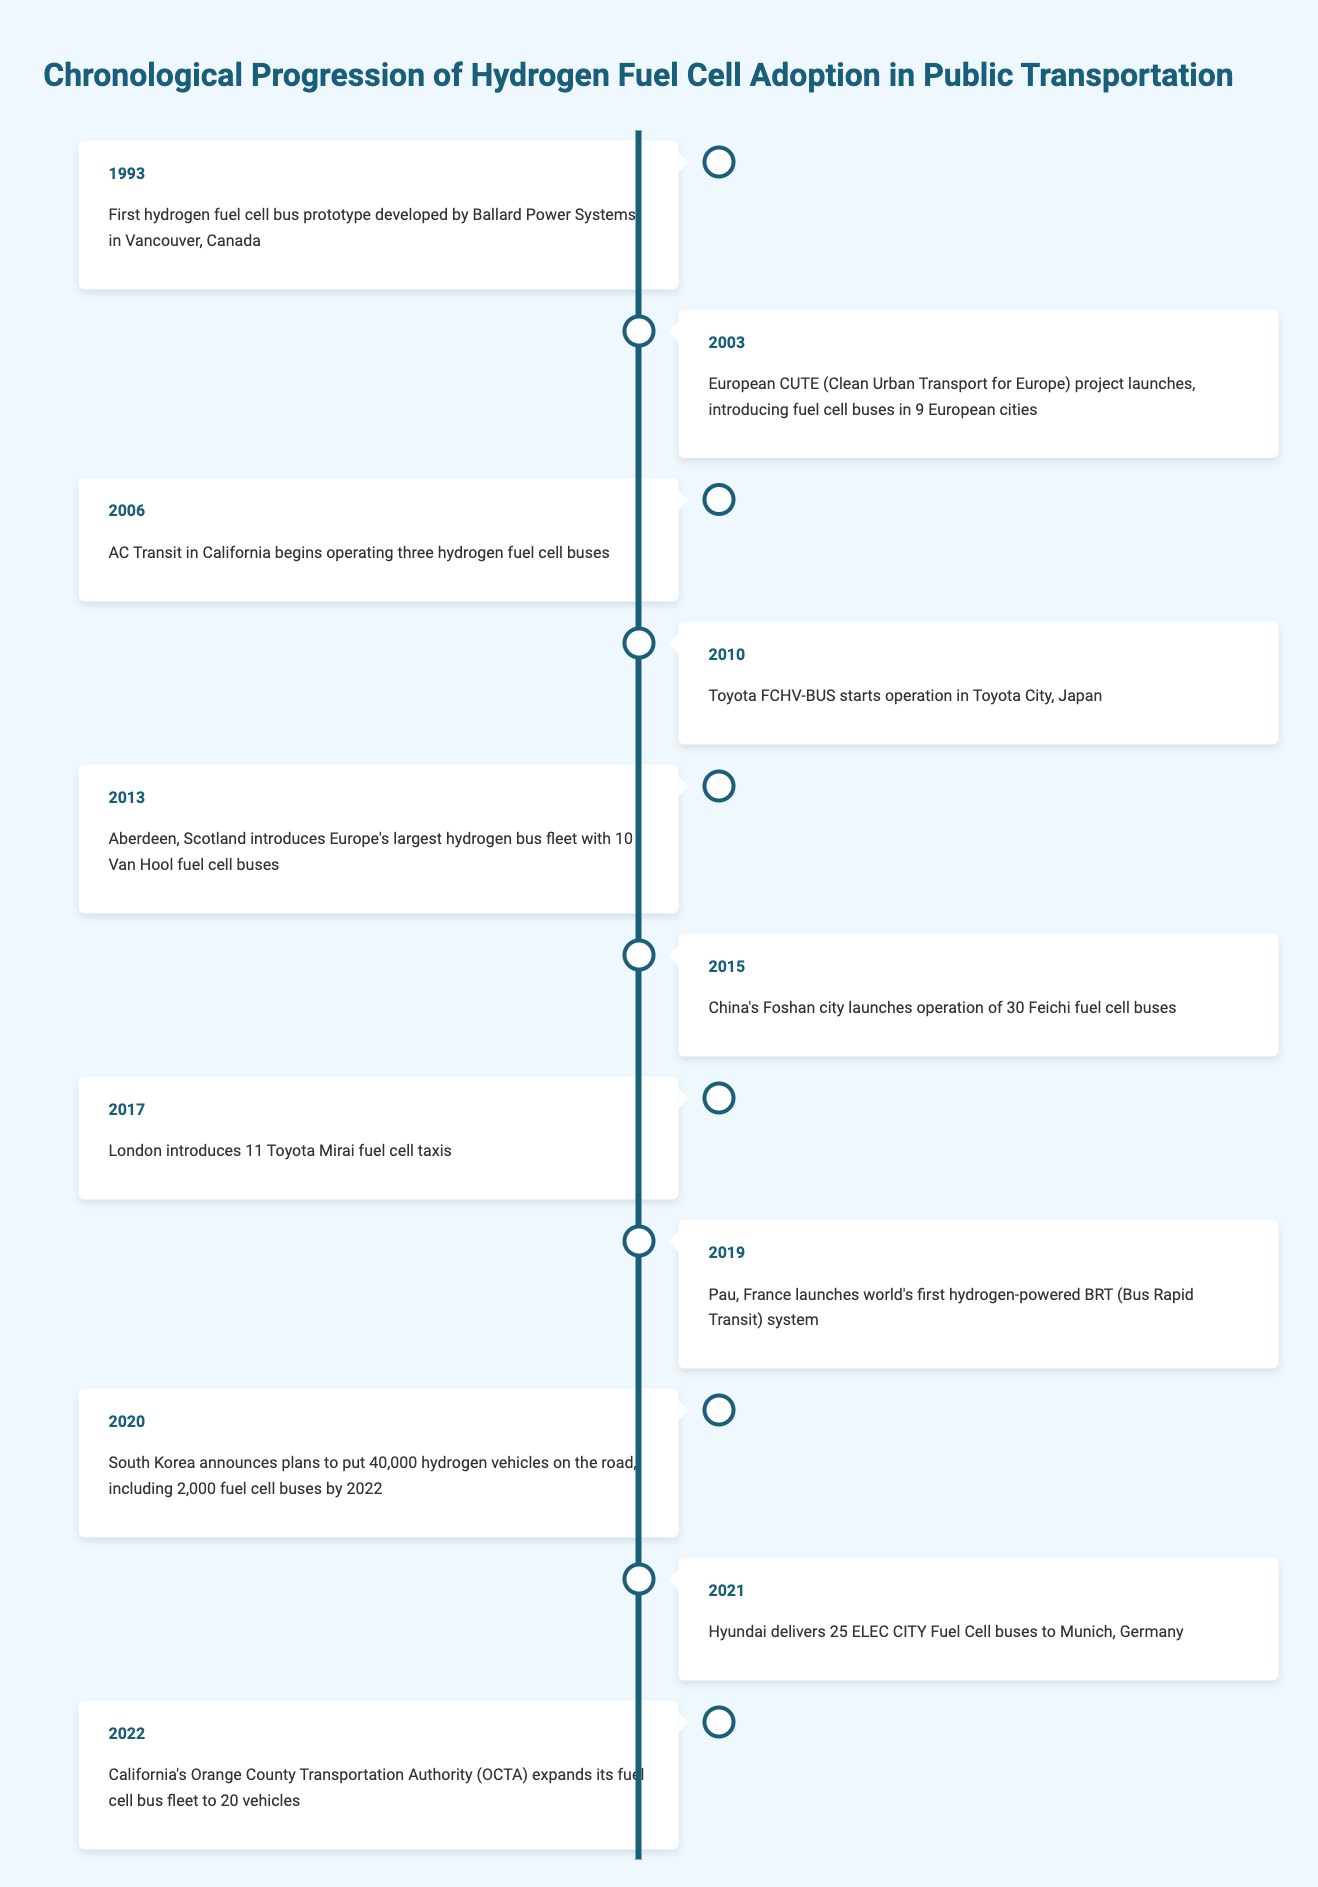What year was the first hydrogen fuel cell bus prototype developed? According to the table, the first hydrogen fuel cell bus prototype was developed in 1993 in Vancouver, Canada.
Answer: 1993 In which year did London introduce fuel cell taxis? The table shows that London introduced 11 Toyota Mirai fuel cell taxis in the year 2017.
Answer: 2017 How many years were there between the launch of the European CUTE project and the introduction of the largest hydrogen bus fleet in Europe? The CUTE project launched in 2003, and the largest hydrogen bus fleet was introduced in 2013. Subtracting the years gives 2013 - 2003 = 10 years.
Answer: 10 years Did South Korea plan to operate fuel cell buses in 2022? Yes, the table states that in 2020, South Korea announced plans to put 2,000 fuel cell buses on the road by 2022.
Answer: Yes Which event occurred closest to 2006? The table lists the events for various years. The closest event to 2006 is in 2003 (the CUTE project) and the next one is in 2010 (Toyota FCHV-BUS). Thus, the events around 2006 are 2003 and 2010.
Answer: 2003 and 2010 What is the total number of hydrogen fuel cell buses operated by California's AC Transit and Aberdeen? AC Transit began operating three hydrogen fuel cell buses in 2006, and Aberdeen introduced 10 fuel cell buses in 2013. Adding them gives 3 + 10 = 13 buses.
Answer: 13 buses In what year did California's Orange County Transportation Authority expand its fuel cell bus fleet? The table indicates that California's Orange County Transportation Authority expanded its fuel cell bus fleet in 2022.
Answer: 2022 How many fuel cell buses were introduced by China in 2015? According to the table, in 2015, China launched the operation of 30 Feichi fuel cell buses in Foshan city.
Answer: 30 fuel cell buses What is the average year of introduction of hydrogen fuel cell buses based on the events listed? To find the average year, sum the years from the events (1993 + 2003 + 2006 + 2010 + 2013 + 2015 + 2017 + 2019 + 2020 + 2021 + 2022 =  2019) and divide by the total number of events (11). The average year is 2019/11 = 2019.
Answer: 2019 